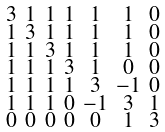Convert formula to latex. <formula><loc_0><loc_0><loc_500><loc_500>\begin{smallmatrix} 3 & 1 & 1 & 1 & 1 & 1 & 0 \\ 1 & 3 & 1 & 1 & 1 & 1 & 0 \\ 1 & 1 & 3 & 1 & 1 & 1 & 0 \\ 1 & 1 & 1 & 3 & 1 & 0 & 0 \\ 1 & 1 & 1 & 1 & 3 & - 1 & 0 \\ 1 & 1 & 1 & 0 & - 1 & 3 & 1 \\ 0 & 0 & 0 & 0 & 0 & 1 & 3 \end{smallmatrix}</formula> 